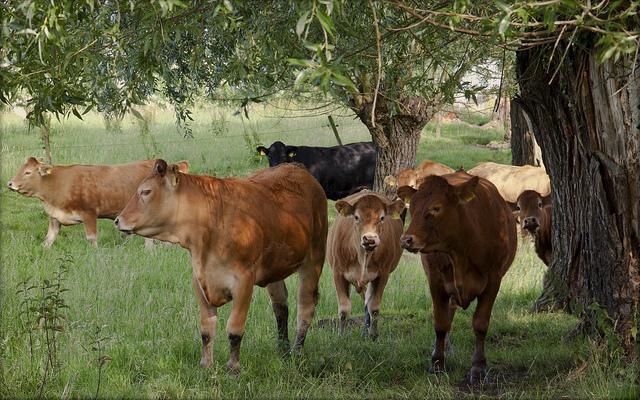How many cows are in the scene?
Give a very brief answer. 7. How many cows can be seen?
Give a very brief answer. 6. How many giraffes are sitting?
Give a very brief answer. 0. 